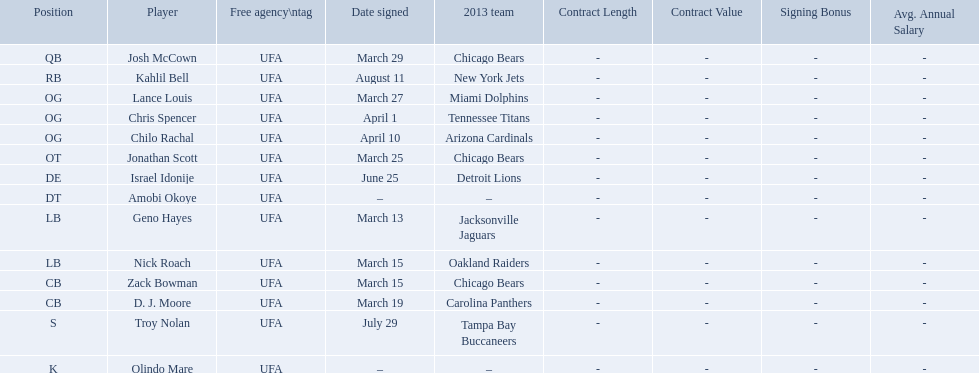Who are all the players on the 2013 chicago bears season team? Josh McCown, Kahlil Bell, Lance Louis, Chris Spencer, Chilo Rachal, Jonathan Scott, Israel Idonije, Amobi Okoye, Geno Hayes, Nick Roach, Zack Bowman, D. J. Moore, Troy Nolan, Olindo Mare. What day was nick roach signed? March 15. What other day matches this? March 15. Who was signed on the day? Zack Bowman. 